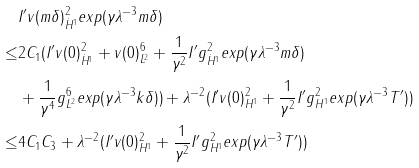<formula> <loc_0><loc_0><loc_500><loc_500>& \| I ^ { \prime } v ( m \delta ) \| ^ { 2 } _ { \dot { H } ^ { 1 } } e x p ( \gamma \lambda ^ { - 3 } m \delta ) \\ \leq & 2 C _ { 1 } ( \| I ^ { \prime } v ( 0 ) \| ^ { 2 } _ { \dot { H } ^ { 1 } } + \| v ( 0 ) \| ^ { 6 } _ { L ^ { 2 } } + \frac { 1 } { \gamma ^ { 2 } } \| I ^ { \prime } g \| ^ { 2 } _ { \dot { H } ^ { 1 } } e x p ( \gamma \lambda ^ { - 3 } m \delta ) \\ & + \frac { 1 } { \gamma ^ { 4 } } \| g \| ^ { 6 } _ { L ^ { 2 } } e x p ( \gamma \lambda ^ { - 3 } k \delta ) ) + \lambda ^ { - 2 } ( \| I ^ { \prime } v ( 0 ) \| _ { H ^ { 1 } } ^ { 2 } + \frac { 1 } { \gamma ^ { 2 } } \| I ^ { \prime } g \| _ { H ^ { 1 } } ^ { 2 } e x p ( \gamma \lambda ^ { - 3 } T ^ { \prime } ) ) \\ \leq & 4 C _ { 1 } C _ { 3 } + \lambda ^ { - 2 } ( \| I ^ { \prime } v ( 0 ) \| _ { H ^ { 1 } } ^ { 2 } + \frac { 1 } { \gamma ^ { 2 } } \| I ^ { \prime } g \| _ { H ^ { 1 } } ^ { 2 } e x p ( \gamma \lambda ^ { - 3 } T ^ { \prime } ) )</formula> 